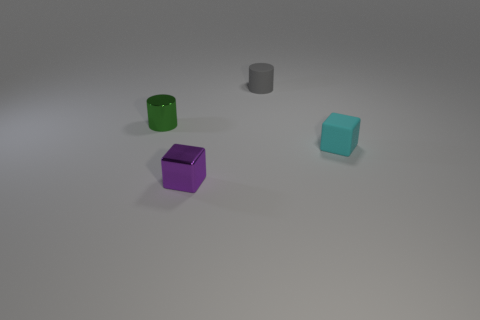Subtract all green cylinders. How many cylinders are left? 1 Subtract 2 cylinders. How many cylinders are left? 0 Subtract all purple balls. How many gray cylinders are left? 1 Add 4 tiny cyan matte things. How many tiny cyan matte things exist? 5 Add 1 yellow cylinders. How many objects exist? 5 Subtract 1 cyan blocks. How many objects are left? 3 Subtract all gray cubes. Subtract all blue cylinders. How many cubes are left? 2 Subtract all purple objects. Subtract all tiny metallic cubes. How many objects are left? 2 Add 2 small objects. How many small objects are left? 6 